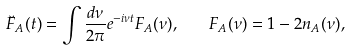<formula> <loc_0><loc_0><loc_500><loc_500>\breve { F } _ { A } ( t ) = \int \frac { d \nu } { 2 \pi } e ^ { - i \nu t } F _ { A } ( \nu ) , \quad F _ { A } ( \nu ) = 1 - 2 n _ { A } ( \nu ) ,</formula> 